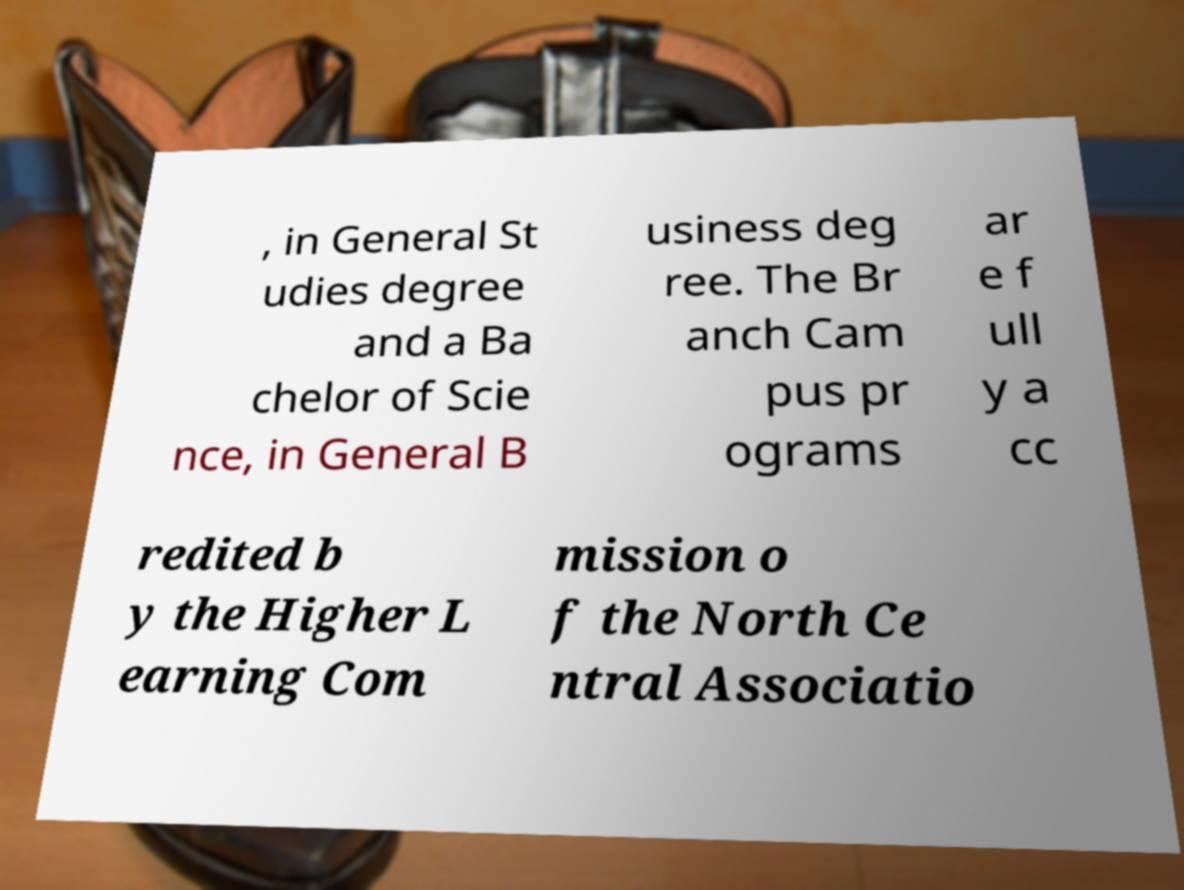What messages or text are displayed in this image? I need them in a readable, typed format. , in General St udies degree and a Ba chelor of Scie nce, in General B usiness deg ree. The Br anch Cam pus pr ograms ar e f ull y a cc redited b y the Higher L earning Com mission o f the North Ce ntral Associatio 